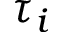<formula> <loc_0><loc_0><loc_500><loc_500>\tau _ { i }</formula> 